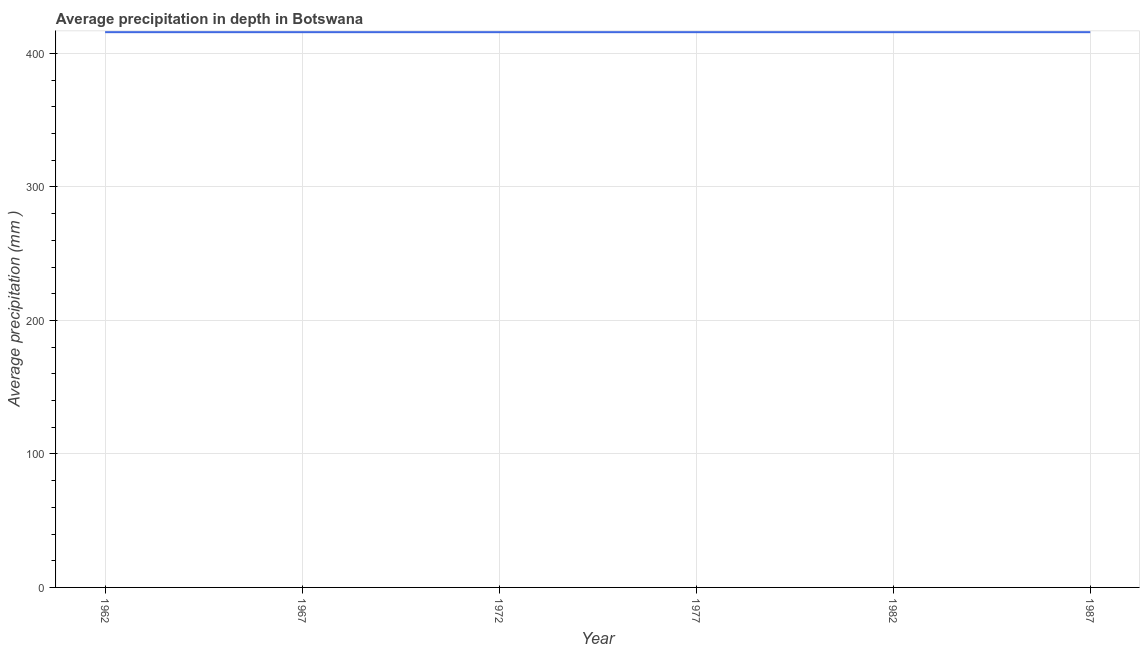What is the average precipitation in depth in 1967?
Keep it short and to the point. 416. Across all years, what is the maximum average precipitation in depth?
Ensure brevity in your answer.  416. Across all years, what is the minimum average precipitation in depth?
Make the answer very short. 416. In which year was the average precipitation in depth maximum?
Offer a terse response. 1962. What is the sum of the average precipitation in depth?
Offer a terse response. 2496. What is the difference between the average precipitation in depth in 1962 and 1987?
Offer a terse response. 0. What is the average average precipitation in depth per year?
Offer a terse response. 416. What is the median average precipitation in depth?
Give a very brief answer. 416. What is the ratio of the average precipitation in depth in 1967 to that in 1987?
Make the answer very short. 1. Is the average precipitation in depth in 1967 less than that in 1987?
Your answer should be very brief. No. Is the difference between the average precipitation in depth in 1967 and 1977 greater than the difference between any two years?
Give a very brief answer. Yes. What is the difference between the highest and the second highest average precipitation in depth?
Your response must be concise. 0. What is the difference between the highest and the lowest average precipitation in depth?
Provide a succinct answer. 0. How many years are there in the graph?
Offer a very short reply. 6. What is the difference between two consecutive major ticks on the Y-axis?
Provide a short and direct response. 100. Are the values on the major ticks of Y-axis written in scientific E-notation?
Ensure brevity in your answer.  No. Does the graph contain any zero values?
Your response must be concise. No. Does the graph contain grids?
Give a very brief answer. Yes. What is the title of the graph?
Your answer should be very brief. Average precipitation in depth in Botswana. What is the label or title of the Y-axis?
Provide a short and direct response. Average precipitation (mm ). What is the Average precipitation (mm ) of 1962?
Your response must be concise. 416. What is the Average precipitation (mm ) of 1967?
Your answer should be compact. 416. What is the Average precipitation (mm ) of 1972?
Offer a very short reply. 416. What is the Average precipitation (mm ) in 1977?
Give a very brief answer. 416. What is the Average precipitation (mm ) in 1982?
Your response must be concise. 416. What is the Average precipitation (mm ) of 1987?
Make the answer very short. 416. What is the difference between the Average precipitation (mm ) in 1962 and 1972?
Provide a succinct answer. 0. What is the difference between the Average precipitation (mm ) in 1962 and 1977?
Make the answer very short. 0. What is the difference between the Average precipitation (mm ) in 1962 and 1982?
Provide a succinct answer. 0. What is the difference between the Average precipitation (mm ) in 1967 and 1972?
Ensure brevity in your answer.  0. What is the difference between the Average precipitation (mm ) in 1967 and 1977?
Give a very brief answer. 0. What is the difference between the Average precipitation (mm ) in 1967 and 1982?
Make the answer very short. 0. What is the difference between the Average precipitation (mm ) in 1967 and 1987?
Provide a short and direct response. 0. What is the difference between the Average precipitation (mm ) in 1977 and 1982?
Provide a short and direct response. 0. What is the difference between the Average precipitation (mm ) in 1977 and 1987?
Keep it short and to the point. 0. What is the difference between the Average precipitation (mm ) in 1982 and 1987?
Offer a very short reply. 0. What is the ratio of the Average precipitation (mm ) in 1962 to that in 1967?
Make the answer very short. 1. What is the ratio of the Average precipitation (mm ) in 1962 to that in 1972?
Your answer should be compact. 1. What is the ratio of the Average precipitation (mm ) in 1962 to that in 1987?
Your answer should be very brief. 1. What is the ratio of the Average precipitation (mm ) in 1972 to that in 1977?
Your answer should be compact. 1. What is the ratio of the Average precipitation (mm ) in 1972 to that in 1982?
Keep it short and to the point. 1. What is the ratio of the Average precipitation (mm ) in 1972 to that in 1987?
Give a very brief answer. 1. What is the ratio of the Average precipitation (mm ) in 1977 to that in 1982?
Keep it short and to the point. 1. 